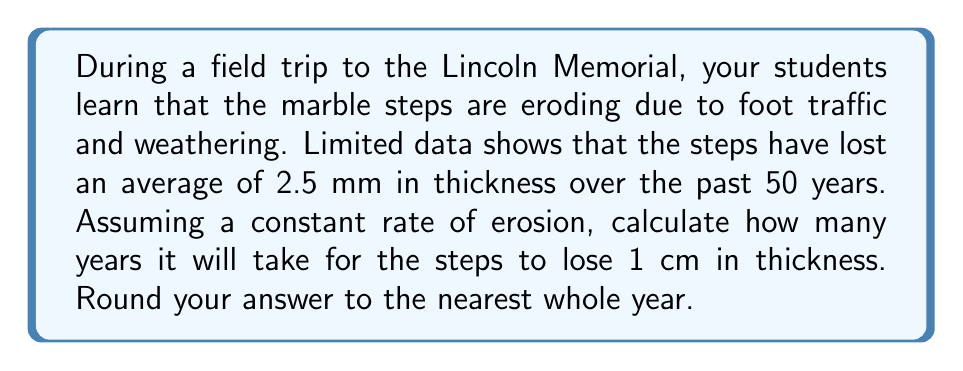Teach me how to tackle this problem. Let's approach this step-by-step:

1) First, we need to determine the rate of erosion per year:
   $$ \text{Rate} = \frac{\text{Total erosion}}{\text{Time period}} $$
   $$ \text{Rate} = \frac{2.5 \text{ mm}}{50 \text{ years}} = 0.05 \text{ mm/year} $$

2) Now, we want to find out how long it will take to erode 1 cm. Let's convert 1 cm to mm:
   $$ 1 \text{ cm} = 10 \text{ mm} $$

3) We can set up an equation where x is the number of years:
   $$ 0.05x = 10 $$

4) Solve for x:
   $$ x = \frac{10}{0.05} = 200 $$

5) Therefore, it will take 200 years for the steps to lose 1 cm in thickness.

This problem demonstrates how we can use limited data points (the erosion over 50 years) to predict future outcomes, which is a key concept in inverse problems. It also relates to the preservation of historical monuments, a topic of interest for a Social Studies teacher planning field trips.
Answer: 200 years 